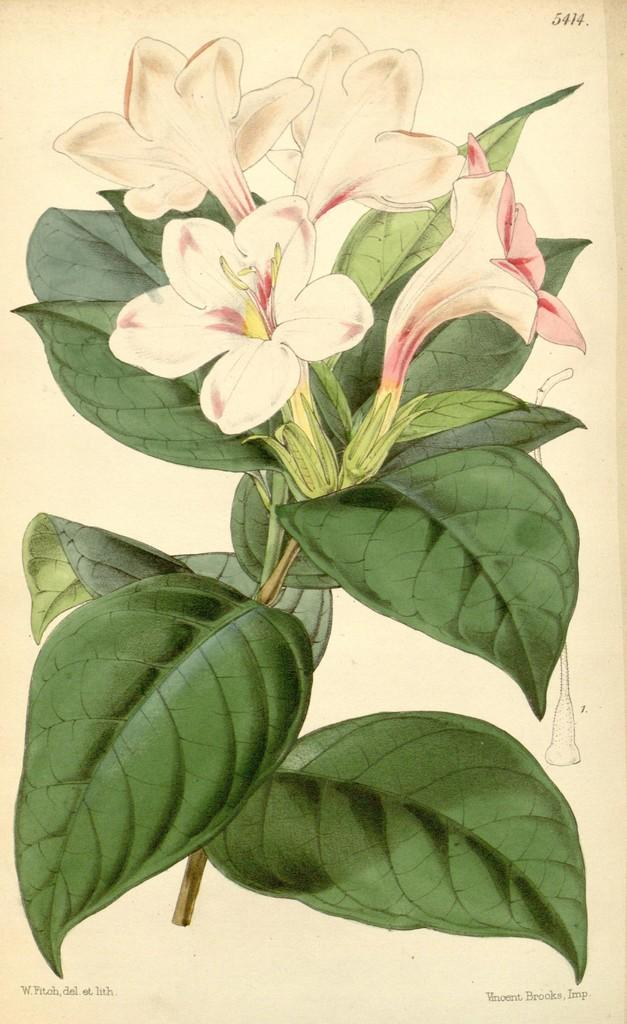What is the main subject of the painting in the image? The painting depicts flowers. Are there any other elements in the painting besides flowers? Yes, the painting also includes green leaves. What type of lock is used to secure the suit in the aftermath of the painting? There is no suit or lock present in the image, as it only features a painting of flowers and green leaves. 